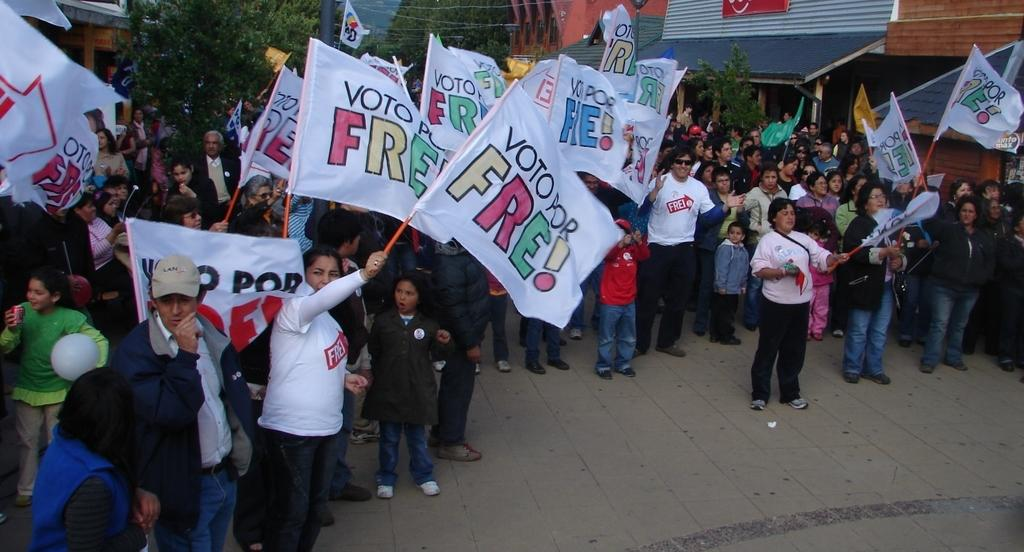How many people are in the image? There is a group of people in the image. What is the lady holding in the image? The lady is holding a flag. What is happening between the person and the lady in the image? A person is speaking to a lady in the image. What type of structures can be seen in the background of the image? There is a row of houses in the image. What type of vegetation is present in the image? There are trees in the image. Can you see the tongue of the tiger in the image? There is no tiger present in the image, so its tongue cannot be seen. How does the wind affect the trees in the image? The image does not provide information about the wind, so we cannot determine its effect on the trees. 